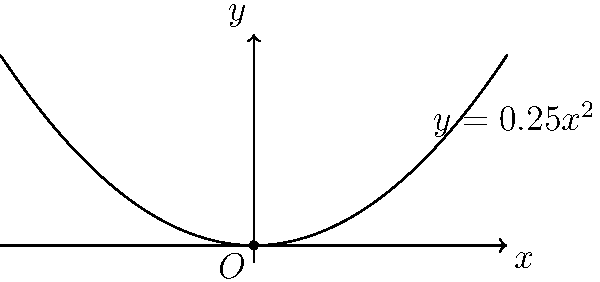For an eco-friendly packaging design, a parabolic logo is being considered. The logo's shape is represented by the equation $y = 0.25x^2$ on a flat surface. Calculate the curvature of this parabola at the origin $(0,0)$. How does this curvature relate to the logo's appearance on the packaging? To find the curvature of the parabola at the origin, we'll follow these steps:

1) The general formula for curvature $K$ at any point $(x,y)$ on a curve $y=f(x)$ is:

   $$K = \frac{|f''(x)|}{(1 + [f'(x)]^2)^{3/2}}$$

2) For our parabola $y = 0.25x^2$, we need to find $f'(x)$ and $f''(x)$:
   
   $f'(x) = 0.5x$
   $f''(x) = 0.5$

3) At the origin $(0,0)$, $x=0$. Let's substitute this into our curvature formula:

   $$K = \frac{|0.5|}{(1 + [0.5(0)]^2)^{3/2}} = \frac{0.5}{1^{3/2}} = 0.5$$

4) Therefore, the curvature at the origin is 0.5.

5) Interpretation for packaging design:
   - A higher curvature value indicates a sharper bend in the curve.
   - The curvature of 0.5 suggests a moderate curve, neither too sharp nor too flat.
   - This moderate curvature would create a gentle, smooth arc in the logo design, which could be visually appealing and easy to print on eco-friendly packaging materials.
   - The symmetrical nature of the parabola around the y-axis ensures a balanced design.
Answer: 0.5 